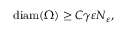<formula> <loc_0><loc_0><loc_500><loc_500>\begin{array} { r } { d i a m ( \Omega ) \geq C \gamma \varepsilon N _ { \varepsilon } , } \end{array}</formula> 